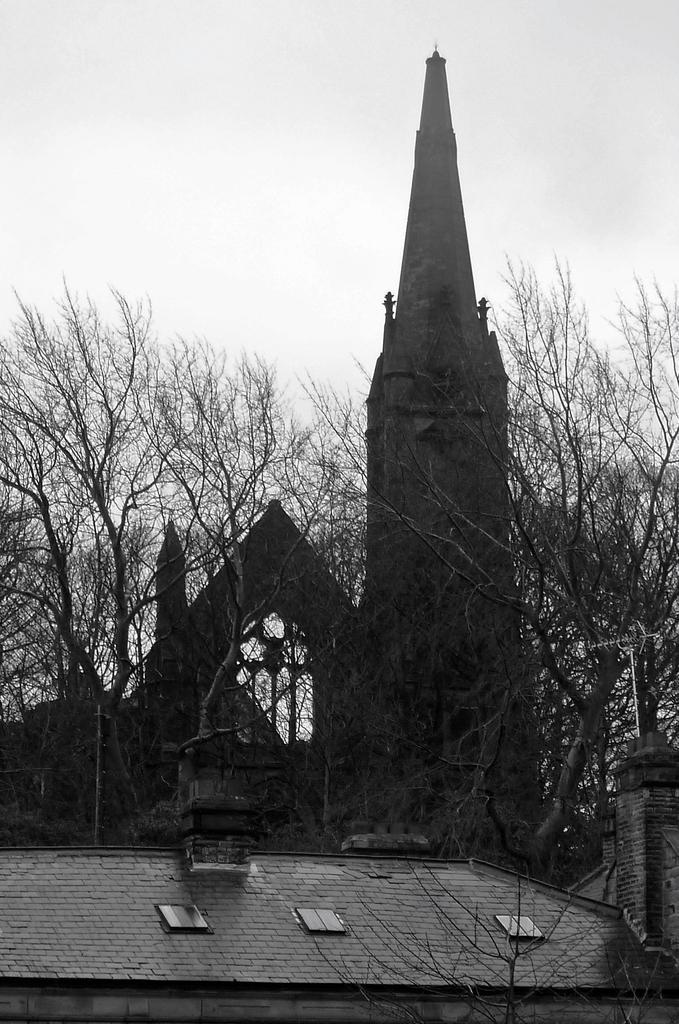What type of structure is in the image? There is an old building in the image. Where is the building located? The building is situated over a place. What can be seen in the image besides the building? There are plants and trees in the image. How would you describe the sky in the image? The sky is cloudy in the image. Is there a cave visible in the image? No, there is no cave present in the image. 